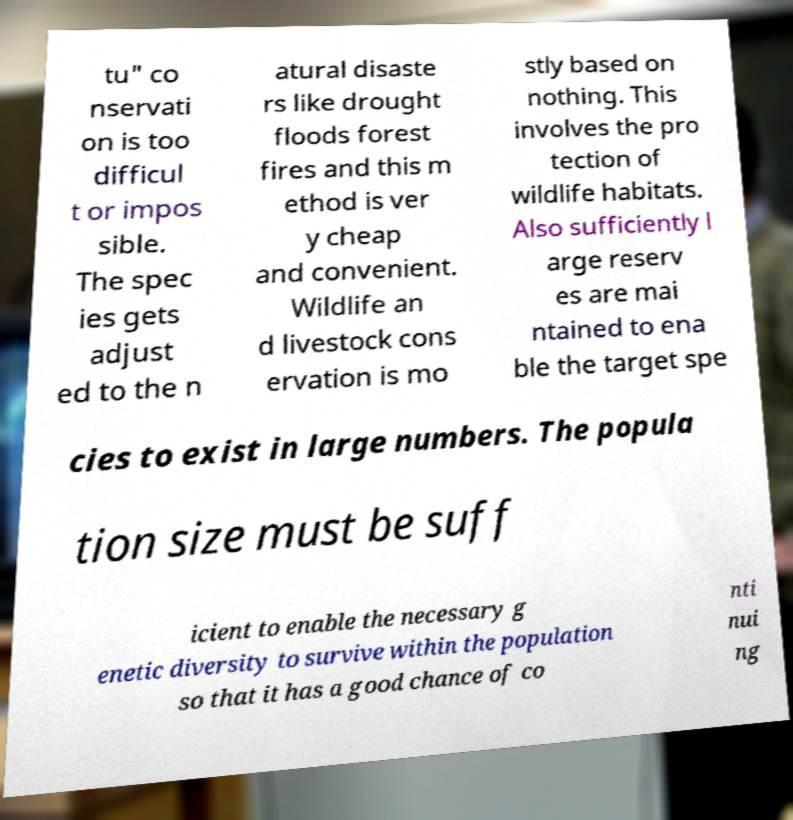Please identify and transcribe the text found in this image. tu" co nservati on is too difficul t or impos sible. The spec ies gets adjust ed to the n atural disaste rs like drought floods forest fires and this m ethod is ver y cheap and convenient. Wildlife an d livestock cons ervation is mo stly based on nothing. This involves the pro tection of wildlife habitats. Also sufficiently l arge reserv es are mai ntained to ena ble the target spe cies to exist in large numbers. The popula tion size must be suff icient to enable the necessary g enetic diversity to survive within the population so that it has a good chance of co nti nui ng 